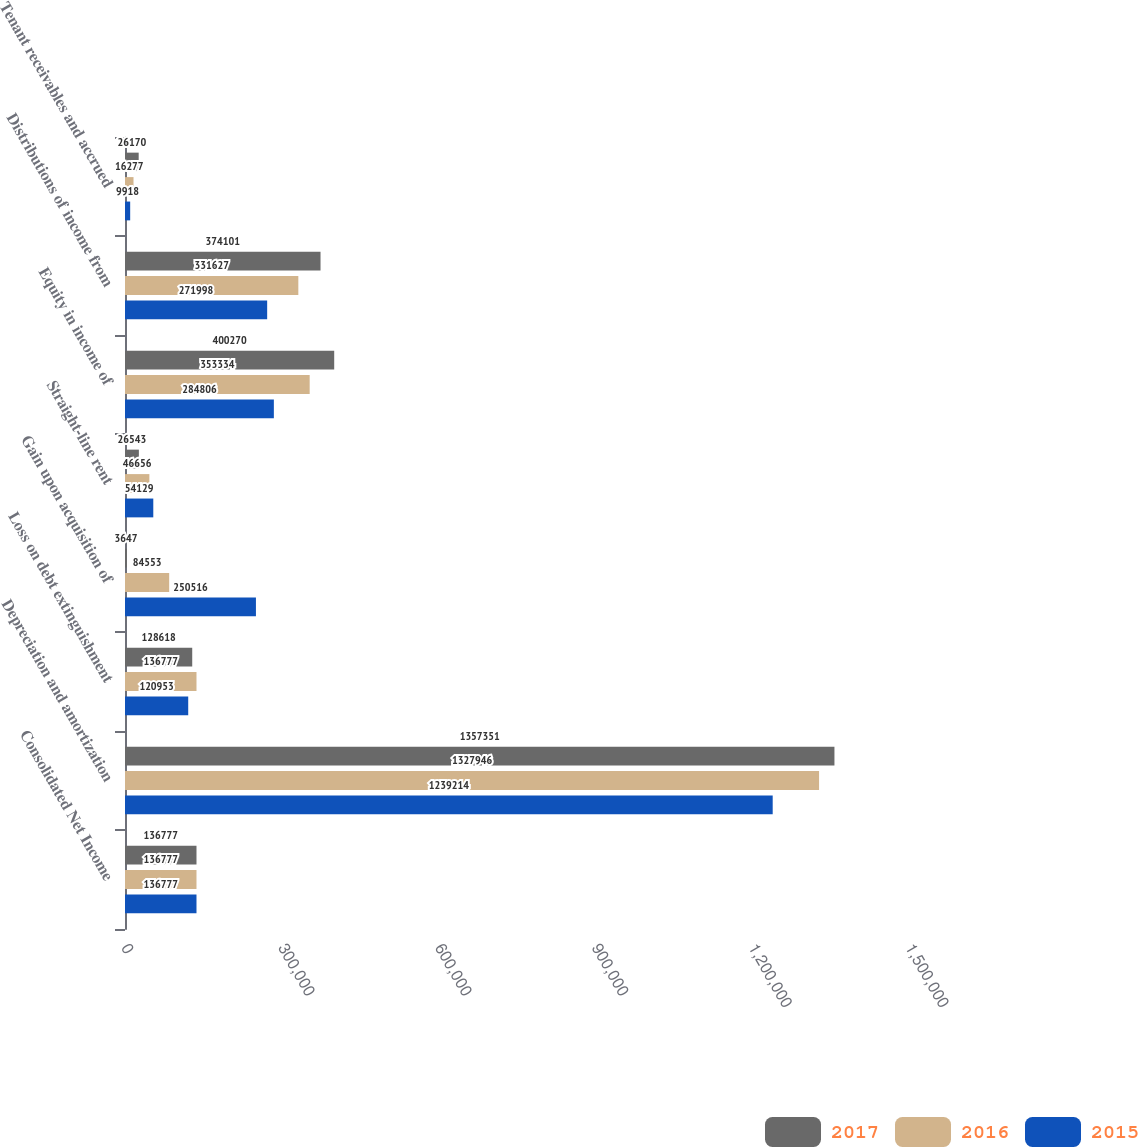Convert chart to OTSL. <chart><loc_0><loc_0><loc_500><loc_500><stacked_bar_chart><ecel><fcel>Consolidated Net Income<fcel>Depreciation and amortization<fcel>Loss on debt extinguishment<fcel>Gain upon acquisition of<fcel>Straight-line rent<fcel>Equity in income of<fcel>Distributions of income from<fcel>Tenant receivables and accrued<nl><fcel>2017<fcel>136777<fcel>1.35735e+06<fcel>128618<fcel>3647<fcel>26543<fcel>400270<fcel>374101<fcel>26170<nl><fcel>2016<fcel>136777<fcel>1.32795e+06<fcel>136777<fcel>84553<fcel>46656<fcel>353334<fcel>331627<fcel>16277<nl><fcel>2015<fcel>136777<fcel>1.23921e+06<fcel>120953<fcel>250516<fcel>54129<fcel>284806<fcel>271998<fcel>9918<nl></chart> 